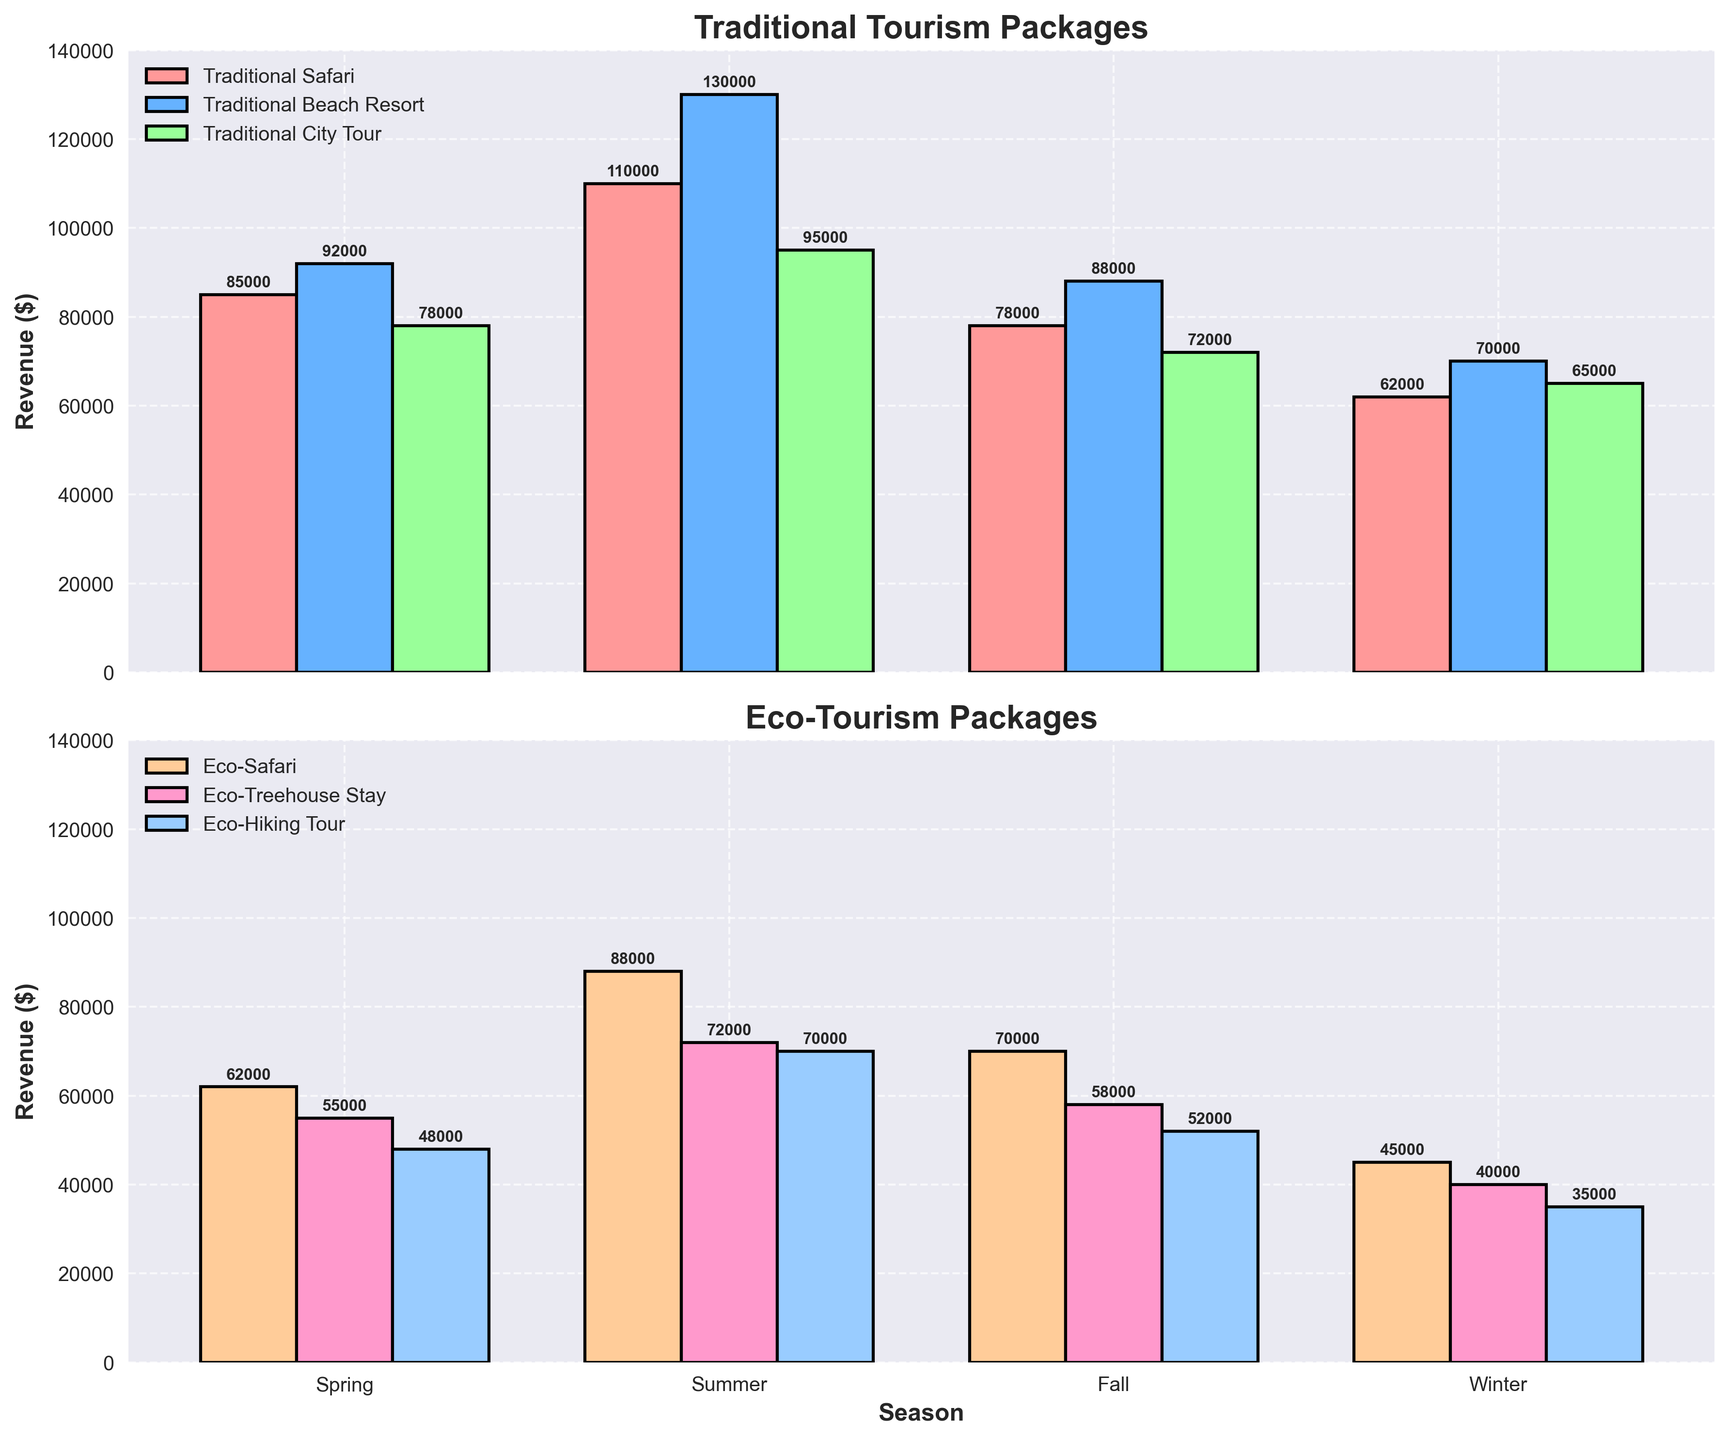Which season has the highest revenue for traditional beach resort packages? Look at the bar heights for the traditional beach resort packages across all seasons. The tallest bar represents the highest revenue.
Answer: Summer What is the total revenue for eco-tourism packages in the spring season? Sum up the values for Eco-Safari, Eco-Treehouse Stay, and Eco-Hiking Tour in the spring season. 62000 + 55000 + 48000 = 165000
Answer: 165000 How does the revenue for eco-safari in winter compare to traditional safari in the same season? Compare the height of the eco-safari bar to the traditional safari bar in winter. The eco-safari has 45000 and the traditional safari has 62000.
Answer: Eco-safari is lower Which eco-tourism package has the highest revenue in fall? Check the heights of the eco-tourism package bars in the fall season. The one with the tallest bar is the highest.
Answer: Eco-Safari Is there any season where the revenue for traditional city tour packages exceeds $100,000? Check the bar heights for traditional city tour packages across all seasons. None of the bars exceed $100,000.
Answer: No Which traditional tourism package shows the most increase from winter to summer? Calculate the differences in revenue from winter to summer for all traditional packages: Traditional Safari: 110000-62000, Traditional Beach Resort: 130000-70000, Traditional City Tour: 95000-65000. Traditional Beach Resort shows the most increase.
Answer: Traditional Beach Resort What is the average revenue across all seasons for the eco-hiking tour? Add the revenues for eco-hiking tour across all seasons and divide by 4. (48000 + 70000 + 52000 + 35000)/4 = 205000/4 = 51250
Answer: 51250 Does spring generate more revenue for traditional safari or eco-safari? Compare the heights of the bars for traditional safari and eco-safari in the spring season. Traditional safari (85000) generates more revenue than eco-safari (62000).
Answer: Traditional safari Which has greater revenue in summer: eco-treehouse stay or traditional city tour? Compare the heights of the bars for eco-treehouse stay (72000) and traditional city tour (95000) in summer. Traditional city tour has greater revenue.
Answer: Traditional city tour What’s the combined revenue of all traditional packages in fall? Sum the values for traditional safari, traditional beach resort, and traditional city tour in fall: 78000 + 88000 + 72000 = 238000
Answer: 238000 